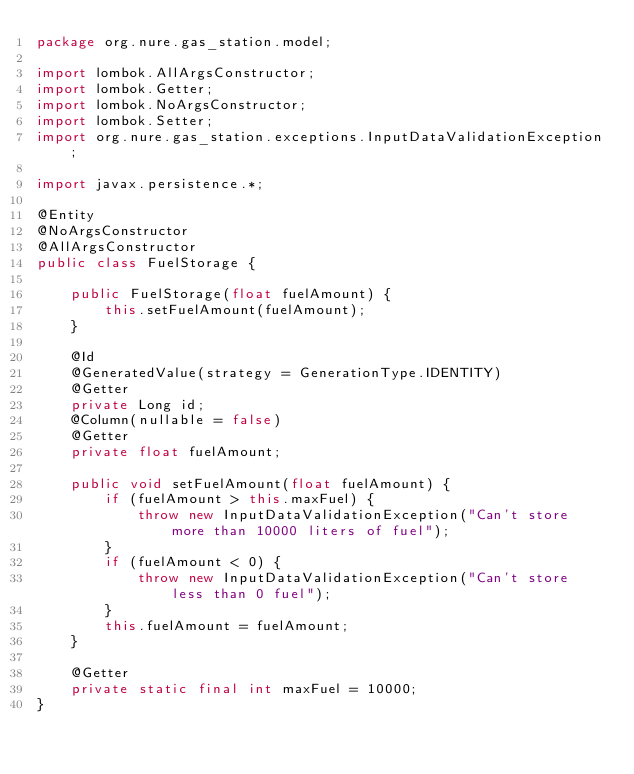<code> <loc_0><loc_0><loc_500><loc_500><_Java_>package org.nure.gas_station.model;

import lombok.AllArgsConstructor;
import lombok.Getter;
import lombok.NoArgsConstructor;
import lombok.Setter;
import org.nure.gas_station.exceptions.InputDataValidationException;

import javax.persistence.*;

@Entity
@NoArgsConstructor
@AllArgsConstructor
public class FuelStorage {

    public FuelStorage(float fuelAmount) {
        this.setFuelAmount(fuelAmount);
    }

    @Id
    @GeneratedValue(strategy = GenerationType.IDENTITY)
    @Getter
    private Long id;
    @Column(nullable = false)
    @Getter
    private float fuelAmount;

    public void setFuelAmount(float fuelAmount) {
        if (fuelAmount > this.maxFuel) {
            throw new InputDataValidationException("Can't store more than 10000 liters of fuel");
        }
        if (fuelAmount < 0) {
            throw new InputDataValidationException("Can't store less than 0 fuel");
        }
        this.fuelAmount = fuelAmount;
    }

    @Getter
    private static final int maxFuel = 10000;
}
</code> 